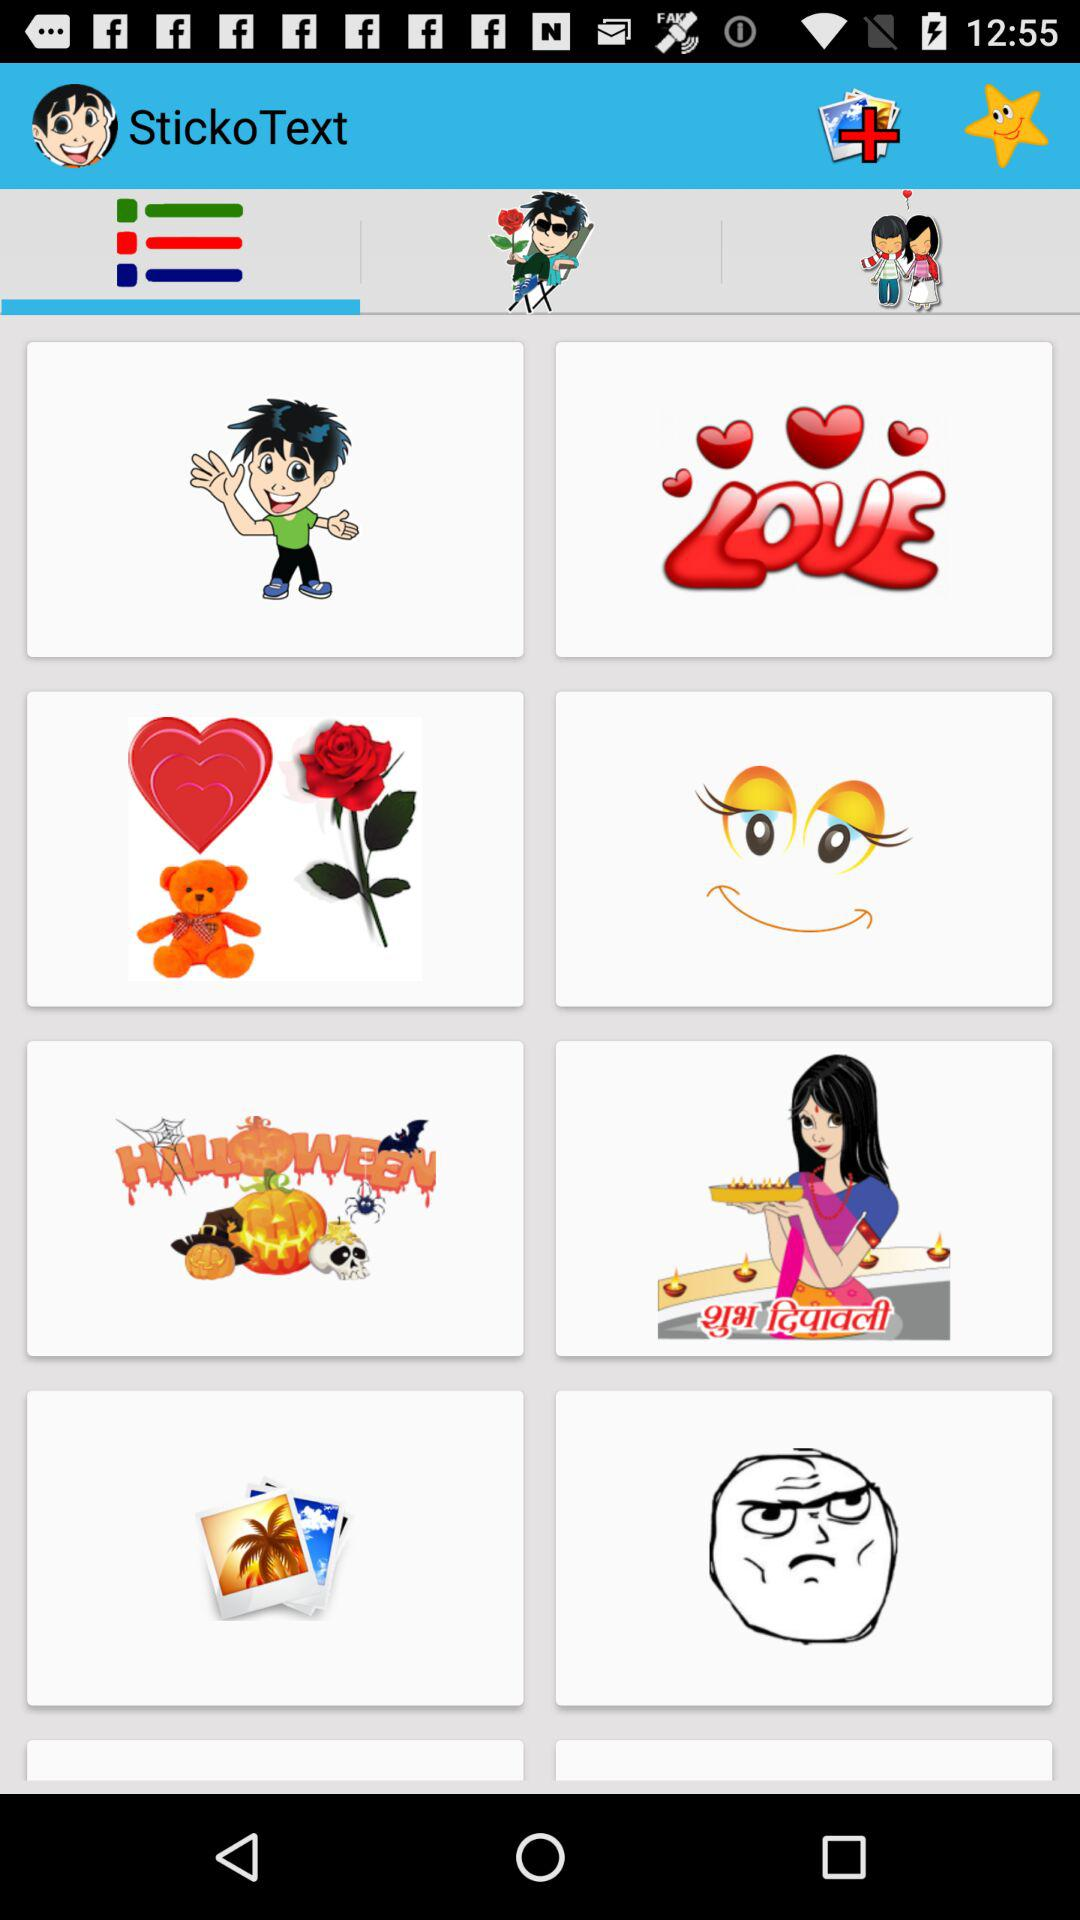What is the application name? The application name is "StickoText". 